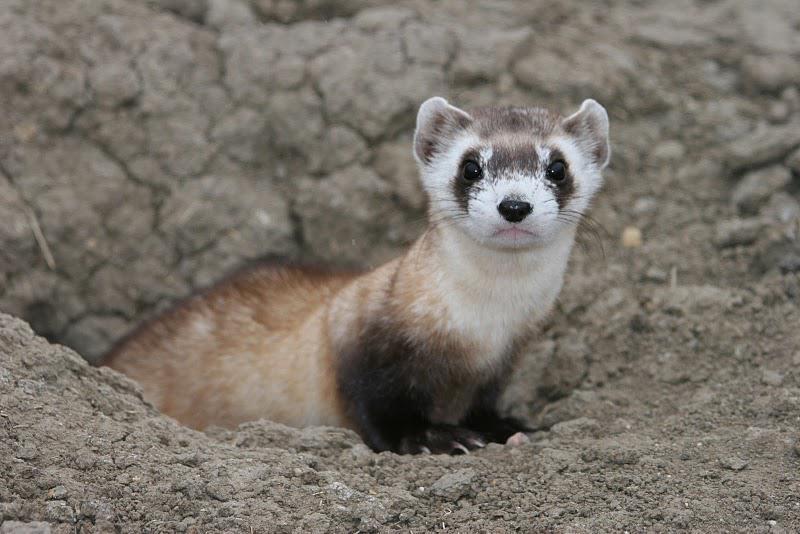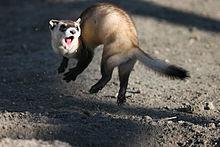The first image is the image on the left, the second image is the image on the right. Given the left and right images, does the statement "ferrets mouth is open wide" hold true? Answer yes or no. Yes. The first image is the image on the left, the second image is the image on the right. Evaluate the accuracy of this statement regarding the images: "At least one of the images shows a ferret with it's mouth wide open.". Is it true? Answer yes or no. Yes. 